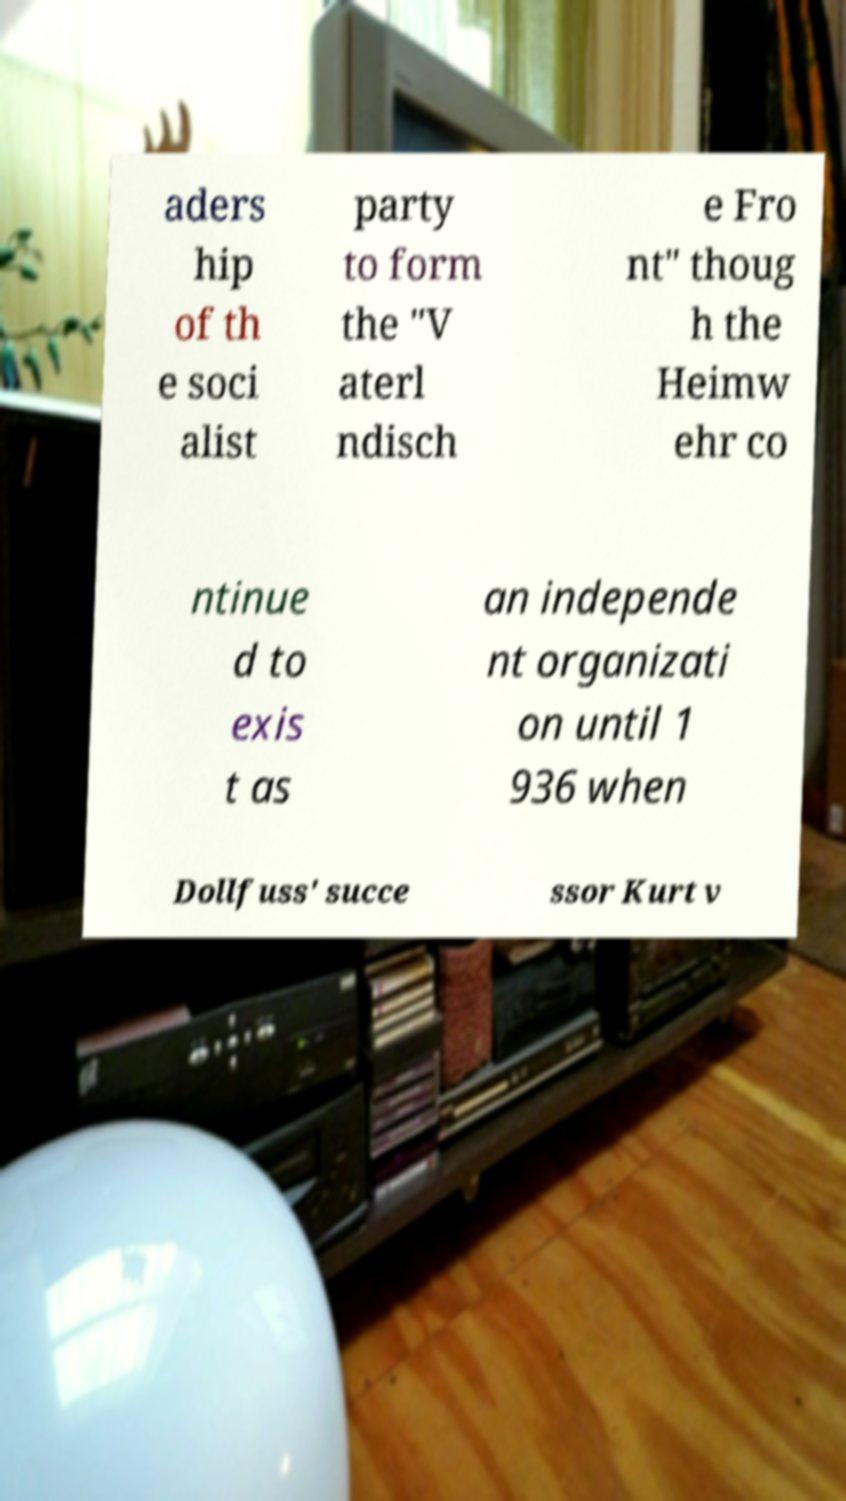I need the written content from this picture converted into text. Can you do that? aders hip of th e soci alist party to form the "V aterl ndisch e Fro nt" thoug h the Heimw ehr co ntinue d to exis t as an independe nt organizati on until 1 936 when Dollfuss' succe ssor Kurt v 